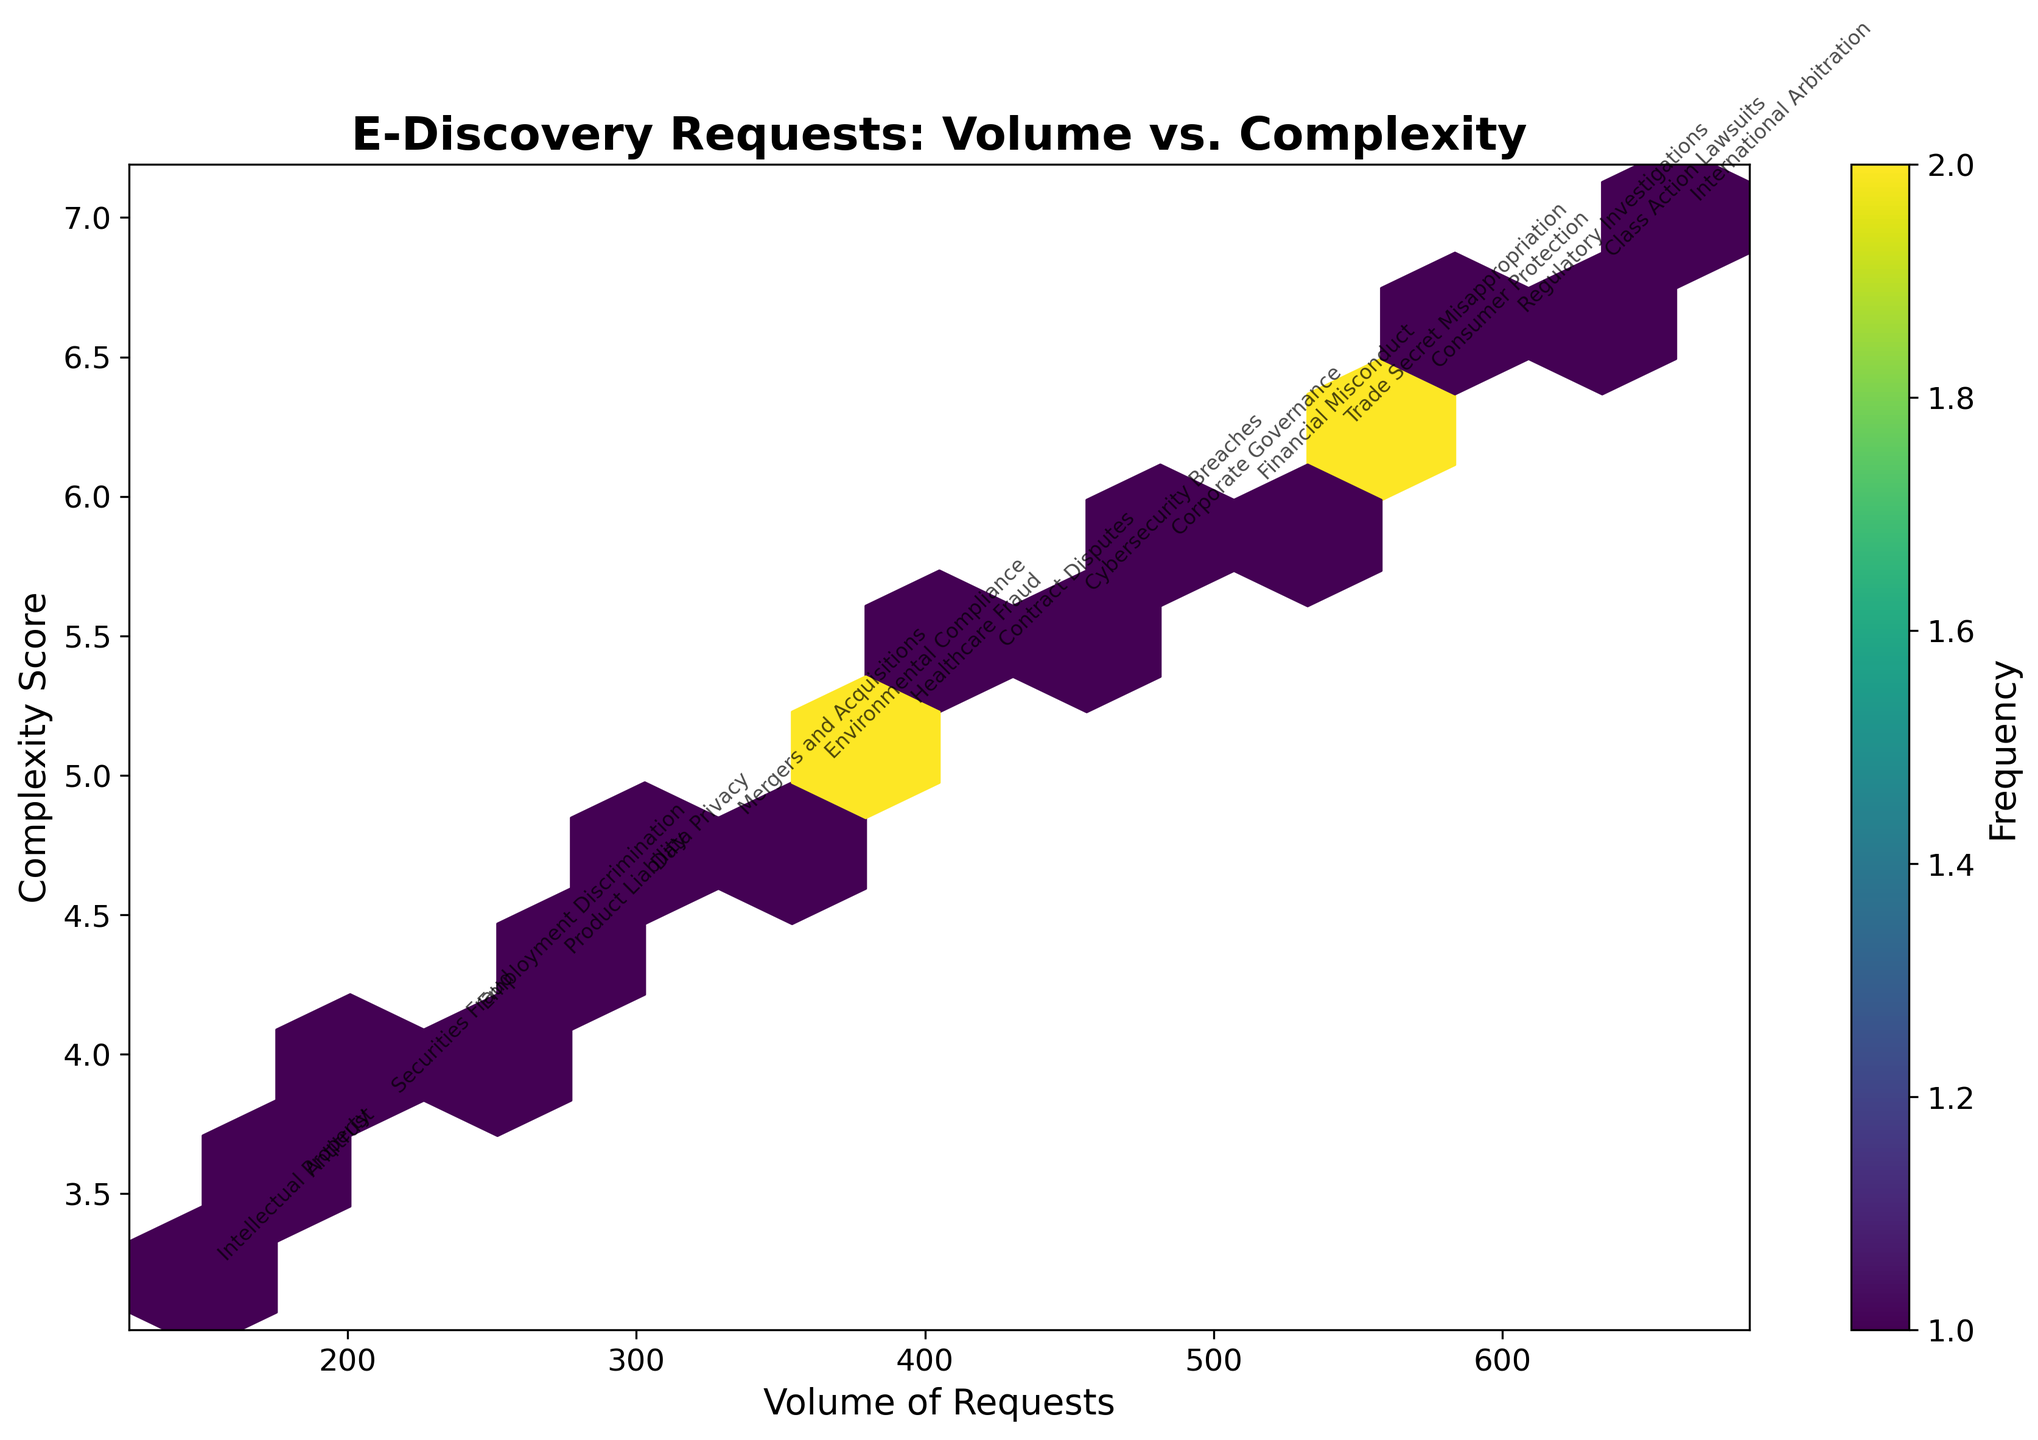What is the title of the hexbin plot? The title can be seen at the top of the hexbin plot.
Answer: E-Discovery Requests: Volume vs. Complexity What do the x and y axes represent? The labels on the x and y axes indicate what each axis represents. The x-axis is labeled "Volume of Requests" and the y-axis is labeled "Complexity Score".
Answer: Volume of Requests (x-axis) and Complexity Score (y-axis) Which case type has the highest complexity score? By identifying the case type with the highest y-value, we can determine that "International Arbitration" has the highest complexity with a score of 7.0.
Answer: International Arbitration What is indicated by the color gradient in the hexbin plot? The color gradient in a hexbin plot typically represents frequency or density of data points. The color bar next to the plot labels this gradient as "Frequency".
Answer: Frequency How does the density of e-discovery requests change from 2020 to 2022? As we move from left to right on the x-axis, which represents increasing volume of requests over time, we see darker hexagons, indicating higher density or frequency of requests in recent years. This suggests an increase in density of e-discovery requests from 2020 to 2022.
Answer: Increase In which year and month do we observe the lowest volume of requests? The data points are annotated with month and year information. By identifying the lowest x-axis value with its corresponding annotations, we find that January 2020 observed the lowest volume of requests.
Answer: January 2020 What is the general trend between the volume of requests and complexity score? By observing the overall distribution of hexagons, we can see that as the volume of requests (x-axis) increases, the complexity score (y-axis) also tends to increase.
Answer: Positive correlation How frequent are e-discovery requests with a volume of approximately 300 and a complexity score around 4.6? The darker the color in the hexbin plot, the more frequent those values occur. By looking at the color of the hexagon around the point (300, 4.6), we can infer the frequency from the color bar, suggesting a higher frequency for requests with these values.
Answer: High frequency Compare the volume of e-discovery requests associated with "Intellectual Property" and "Healthcare Fraud". "Intellectual Property" is associated with a lower volume, around 150, whereas "Healthcare Fraud" is associated with a higher volume, around 390. Hence, Healthcare Fraud has a higher volume of requests compared to Intellectual Property.
Answer: Higher for Healthcare Fraud What can you infer about the trend in complexity scores for requests from 2020 to 2022? Observing the upward slant of hexagons over time (left to right on the x-axis and bottom to top on the y-axis), it is evident that complexity scores tend to increase from 2020 to 2022.
Answer: Increasing 